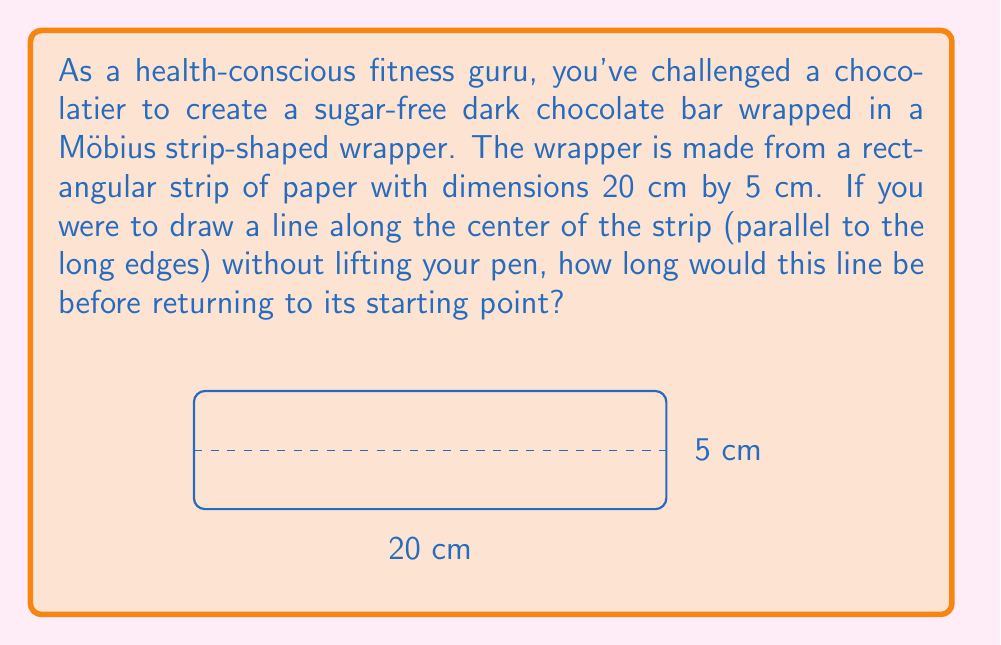Help me with this question. Let's approach this step-by-step:

1) First, recall that a Möbius strip is created by taking a rectangular strip and giving it a half-twist before joining the ends.

2) The key property of a Möbius strip is that it has only one side and one edge. This means that a line drawn down the center will traverse the entire surface before returning to its starting point.

3) In a regular cylinder (without the twist), the line would simply go around once and return to its starting point after traveling the length of the strip (20 cm).

4) However, in a Möbius strip, the line needs to traverse both the "top" and "bottom" of the original rectangle before returning to its starting point.

5) This means that the line will travel the length of the strip twice before returning to its starting point.

6) Therefore, the length of the line will be:

   $$L = 2 \times \text{length of strip} = 2 \times 20\text{ cm} = 40\text{ cm}$$

7) It's worth noting that this result is independent of the width of the strip. The width only affects how many twists the line makes, not its total length.
Answer: 40 cm 